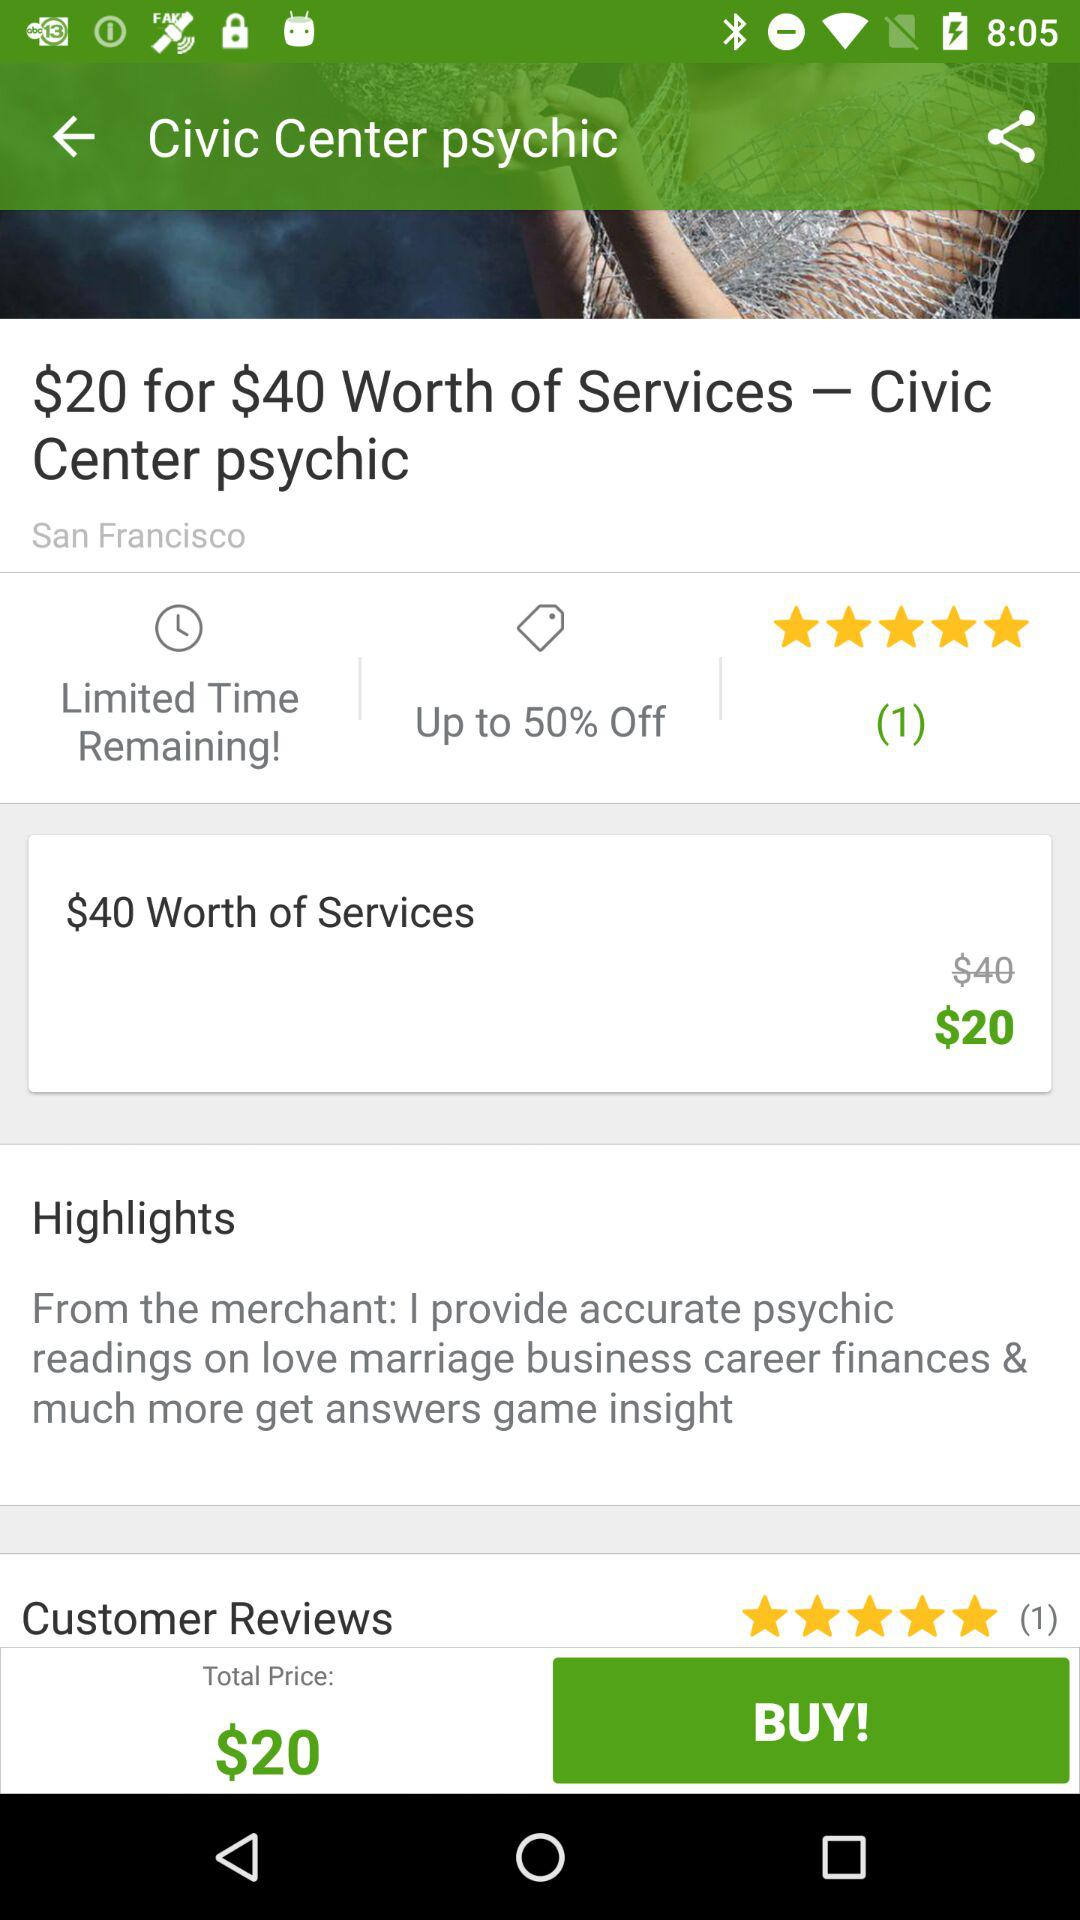What is the rating? The rating is 5 stars. 